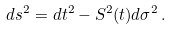<formula> <loc_0><loc_0><loc_500><loc_500>d s ^ { 2 } = d t ^ { 2 } - S ^ { 2 } ( t ) d \sigma ^ { 2 } \, .</formula> 